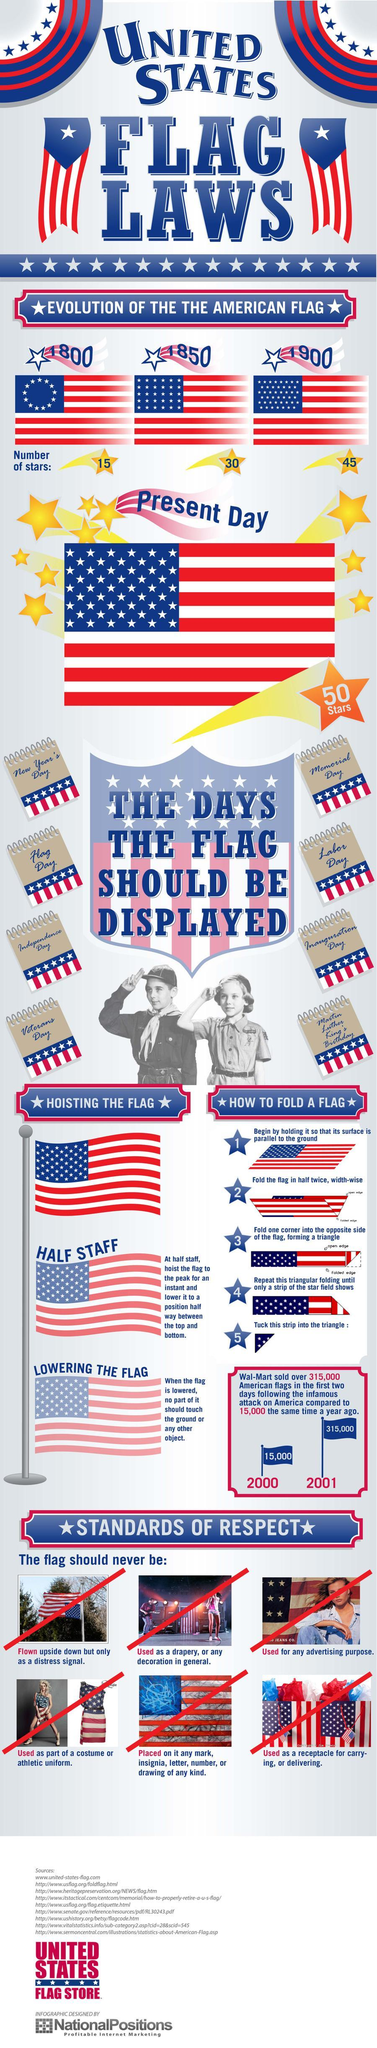What is the no of stars present in the U.S. flag in the year 1900?
Answer the question with a short phrase. 45 How many American flags were sold by Walmart in the year 2001? 315,000 How many American flags were sold by Walmart in the year 2000? 15,000 How many stars are there in the U.S. flag as of today? 50 Which year had the least no of stars in the U.S. flag compared to present day? 1800 What is the no of stars present in the U.S. flag in the year 1850? 30 